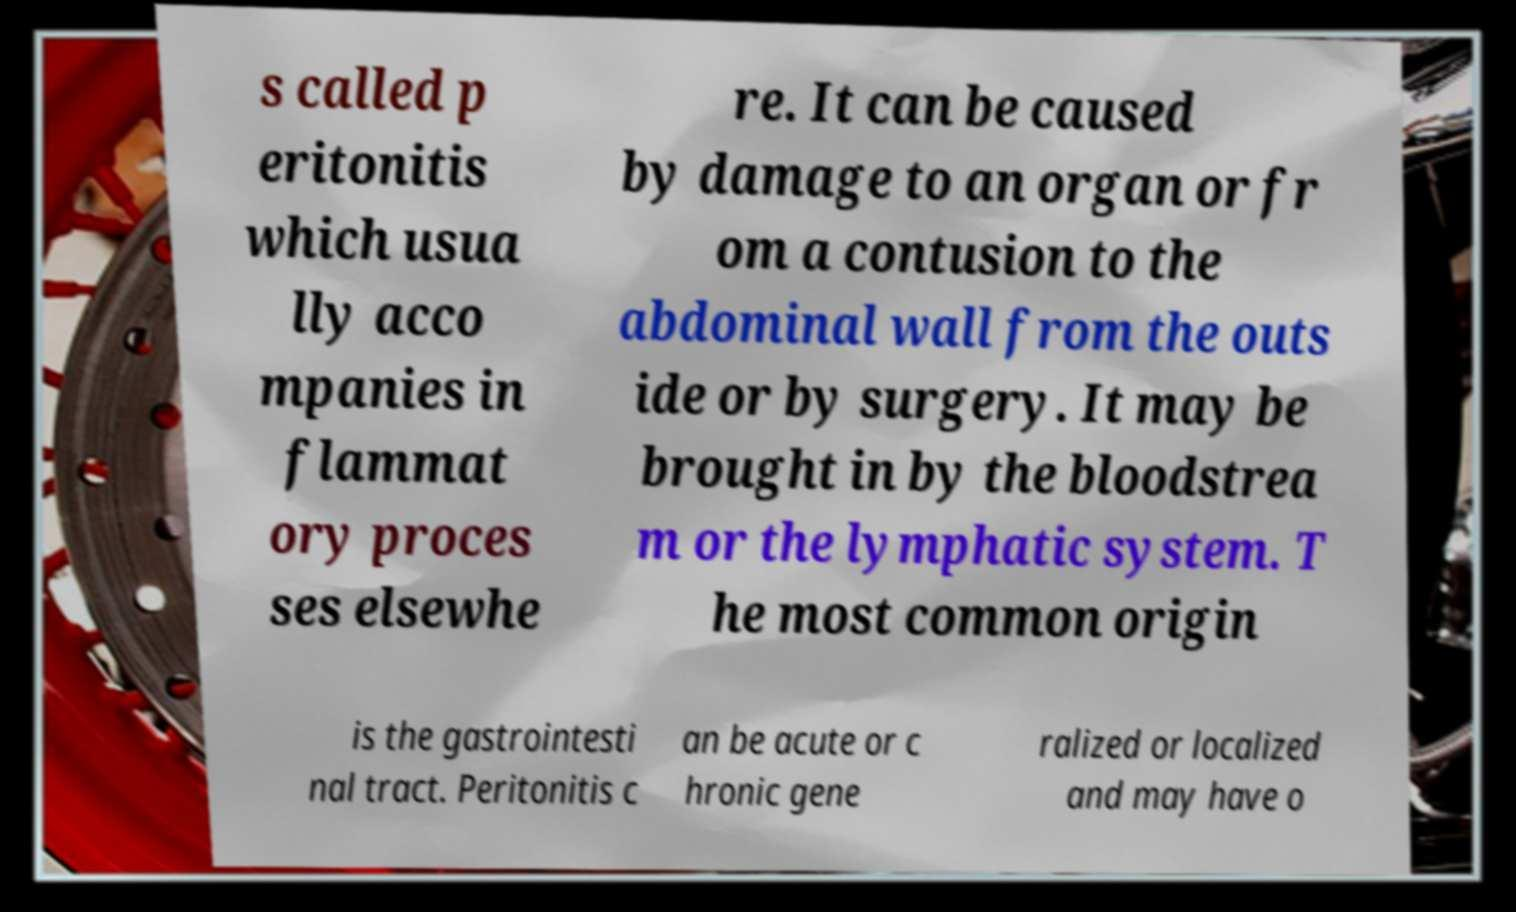Can you accurately transcribe the text from the provided image for me? s called p eritonitis which usua lly acco mpanies in flammat ory proces ses elsewhe re. It can be caused by damage to an organ or fr om a contusion to the abdominal wall from the outs ide or by surgery. It may be brought in by the bloodstrea m or the lymphatic system. T he most common origin is the gastrointesti nal tract. Peritonitis c an be acute or c hronic gene ralized or localized and may have o 